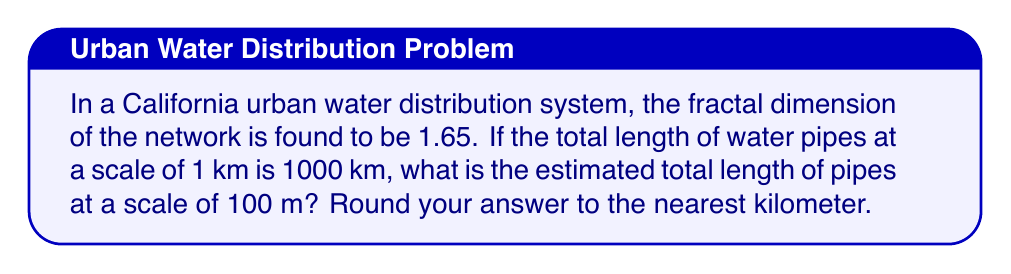Can you answer this question? To solve this problem, we'll use the fractal scaling law, which relates the measured quantity at different scales. Let's approach this step-by-step:

1) The fractal scaling law is given by:

   $$\frac{L_2}{L_1} = \left(\frac{r_2}{r_1}\right)^{1-D}$$

   Where:
   $L_1$ and $L_2$ are the measured lengths at scales $r_1$ and $r_2$ respectively
   $D$ is the fractal dimension

2) We know:
   $L_1 = 1000$ km (at scale $r_1 = 1$ km)
   $r_2 = 100$ m = 0.1 km
   $D = 1.65$

3) Let's substitute these values:

   $$\frac{L_2}{1000} = \left(\frac{0.1}{1}\right)^{1-1.65}$$

4) Simplify the right side:

   $$\frac{L_2}{1000} = (0.1)^{-0.65} = 10^{0.65}$$

5) Solve for $L_2$:

   $$L_2 = 1000 \cdot 10^{0.65} \approx 4466.84$$

6) Rounding to the nearest kilometer:

   $L_2 \approx 4467$ km

This result shows that as we increase the resolution (decrease the scale), we uncover more detail in the fractal network, resulting in a longer total pipe length.
Answer: 4467 km 